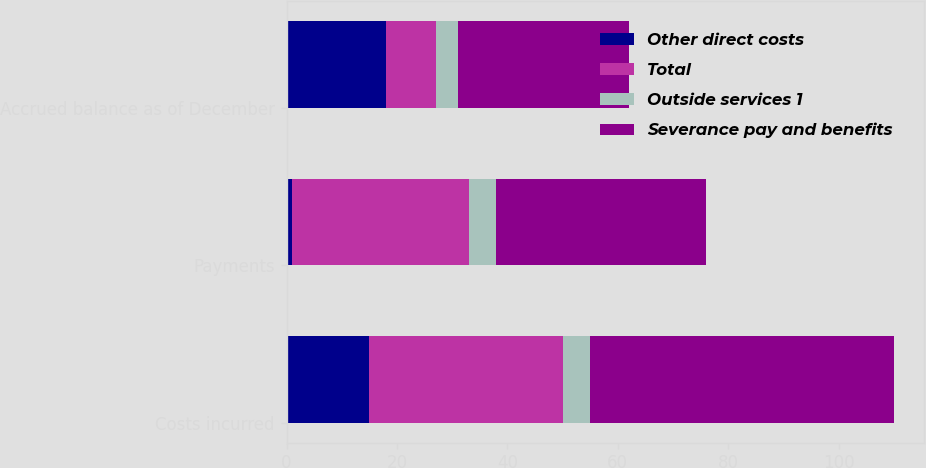Convert chart to OTSL. <chart><loc_0><loc_0><loc_500><loc_500><stacked_bar_chart><ecel><fcel>Costs incurred<fcel>Payments<fcel>Accrued balance as of December<nl><fcel>Other direct costs<fcel>15<fcel>1<fcel>18<nl><fcel>Total<fcel>35<fcel>32<fcel>9<nl><fcel>Outside services 1<fcel>5<fcel>5<fcel>4<nl><fcel>Severance pay and benefits<fcel>55<fcel>38<fcel>31<nl></chart> 